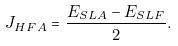<formula> <loc_0><loc_0><loc_500><loc_500>J _ { H F A } = \frac { E _ { S L A } - E _ { S L F } } 2 .</formula> 